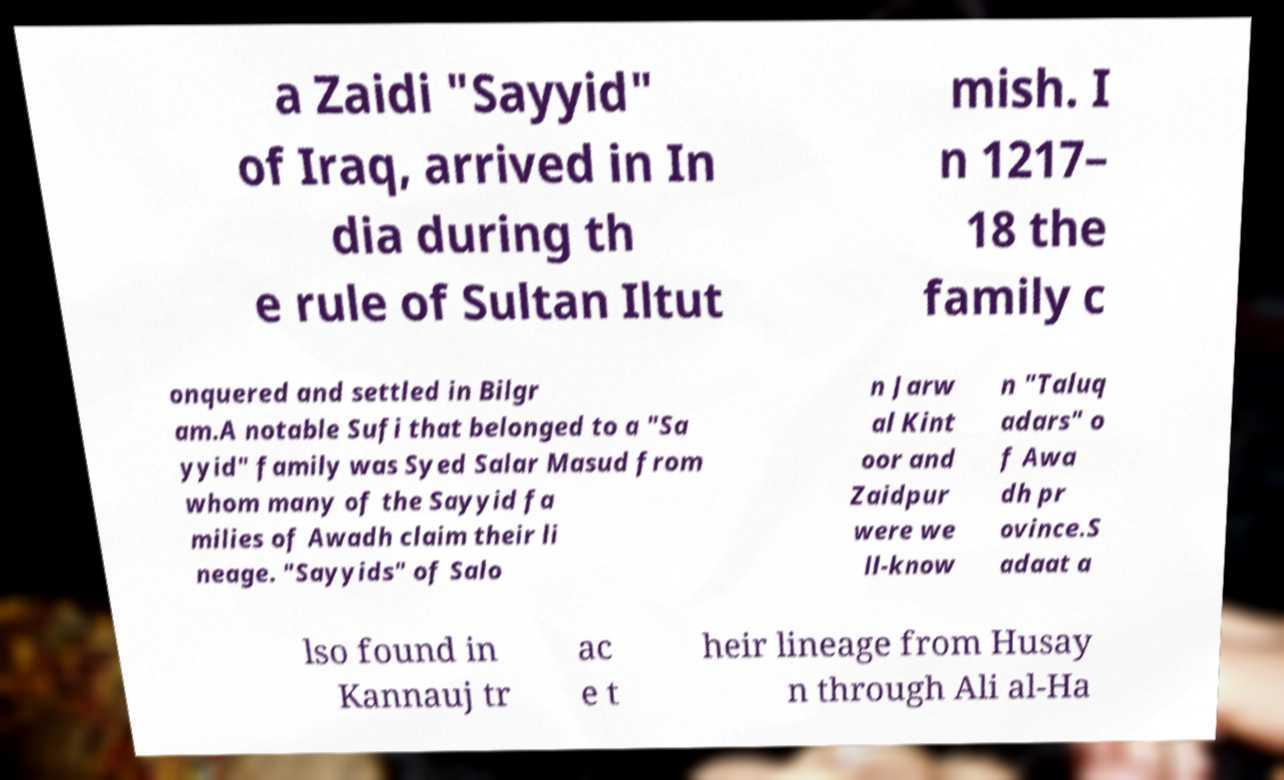Could you assist in decoding the text presented in this image and type it out clearly? a Zaidi "Sayyid" of Iraq, arrived in In dia during th e rule of Sultan Iltut mish. I n 1217– 18 the family c onquered and settled in Bilgr am.A notable Sufi that belonged to a "Sa yyid" family was Syed Salar Masud from whom many of the Sayyid fa milies of Awadh claim their li neage. "Sayyids" of Salo n Jarw al Kint oor and Zaidpur were we ll-know n "Taluq adars" o f Awa dh pr ovince.S adaat a lso found in Kannauj tr ac e t heir lineage from Husay n through Ali al-Ha 